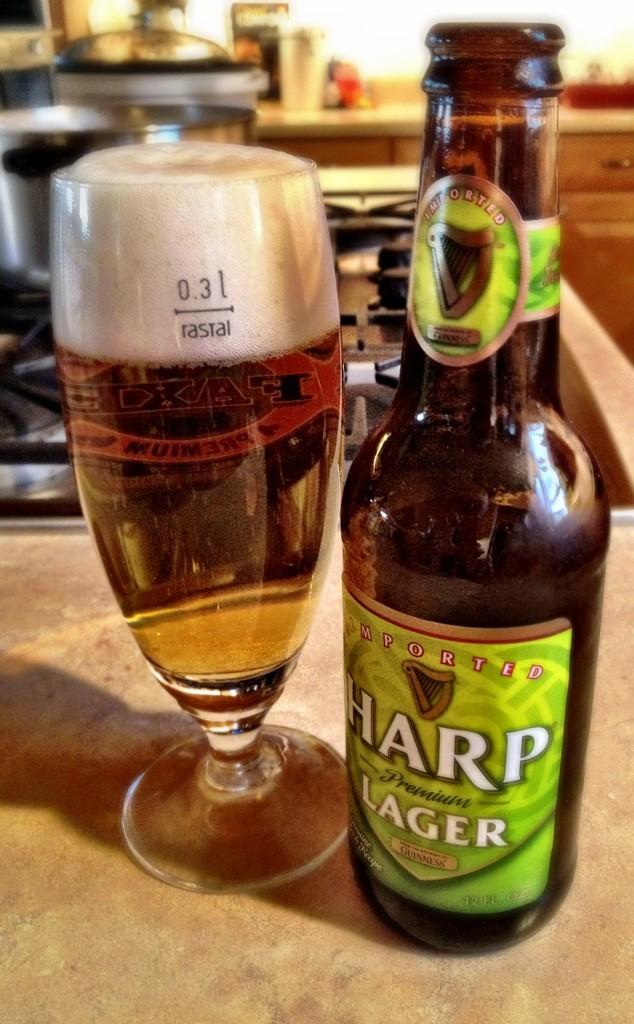<image>
Offer a succinct explanation of the picture presented. A bottle of Harp lager stands next to a glass containing said beverage. 